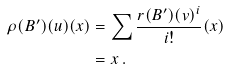Convert formula to latex. <formula><loc_0><loc_0><loc_500><loc_500>\rho ( B ^ { \prime } ) ( u ) ( x ) & = \sum \frac { r ( B ^ { \prime } ) ( v ) ^ { i } } { i ! } ( x ) \\ & = x \, .</formula> 